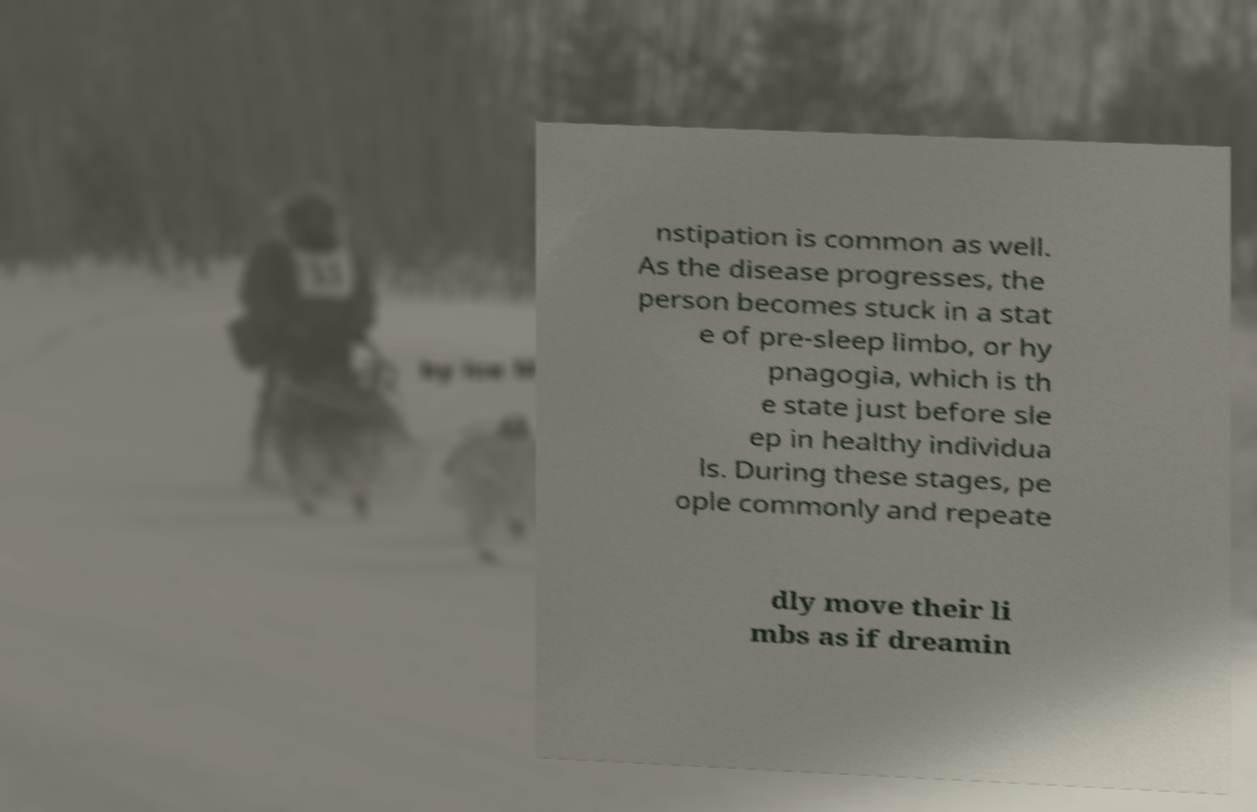Can you read and provide the text displayed in the image?This photo seems to have some interesting text. Can you extract and type it out for me? nstipation is common as well. As the disease progresses, the person becomes stuck in a stat e of pre-sleep limbo, or hy pnagogia, which is th e state just before sle ep in healthy individua ls. During these stages, pe ople commonly and repeate dly move their li mbs as if dreamin 